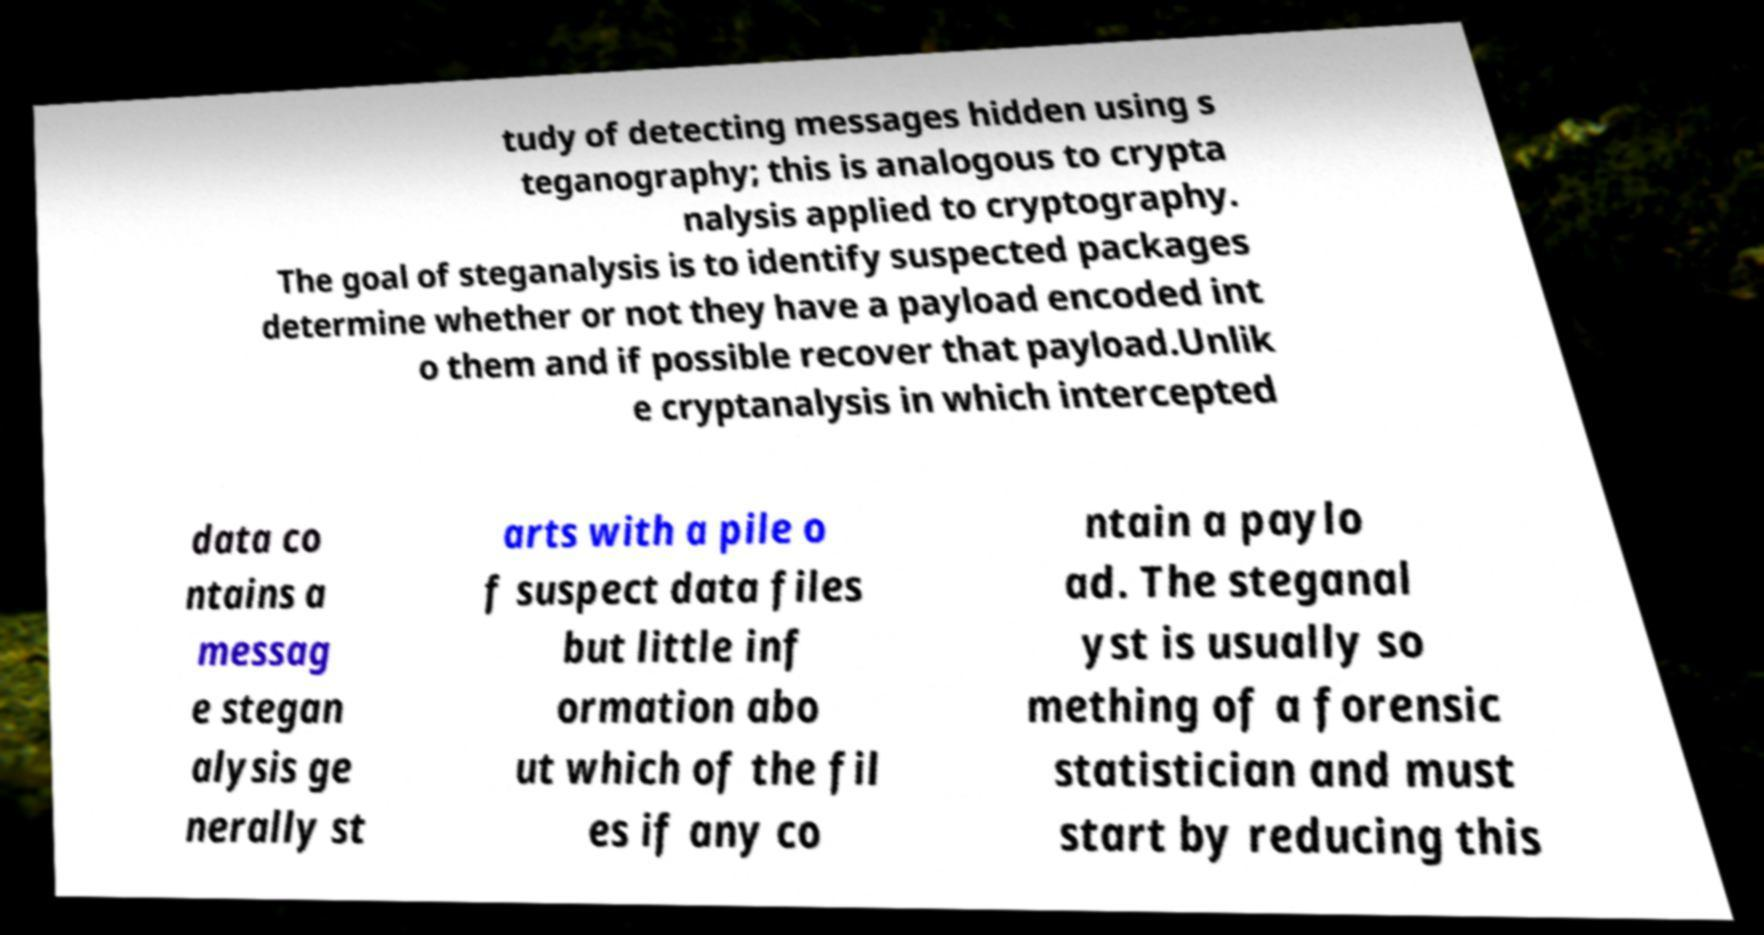Can you read and provide the text displayed in the image?This photo seems to have some interesting text. Can you extract and type it out for me? tudy of detecting messages hidden using s teganography; this is analogous to crypta nalysis applied to cryptography. The goal of steganalysis is to identify suspected packages determine whether or not they have a payload encoded int o them and if possible recover that payload.Unlik e cryptanalysis in which intercepted data co ntains a messag e stegan alysis ge nerally st arts with a pile o f suspect data files but little inf ormation abo ut which of the fil es if any co ntain a paylo ad. The steganal yst is usually so mething of a forensic statistician and must start by reducing this 